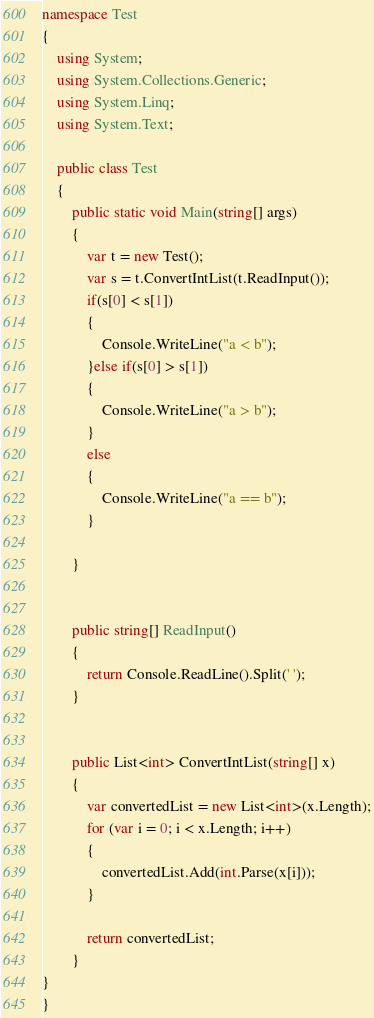<code> <loc_0><loc_0><loc_500><loc_500><_C#_>namespace Test
{
    using System;
    using System.Collections.Generic;
    using System.Linq;
    using System.Text;

    public class Test
    {
        public static void Main(string[] args)
        {
            var t = new Test();
            var s = t.ConvertIntList(t.ReadInput());
            if(s[0] < s[1])
            {
                Console.WriteLine("a < b");
            }else if(s[0] > s[1])
            {
                Console.WriteLine("a > b");
            }
            else
            {
                Console.WriteLine("a == b");
            }
           
        }


        public string[] ReadInput()
        {
            return Console.ReadLine().Split(' ');
        }


        public List<int> ConvertIntList(string[] x)
        {
            var convertedList = new List<int>(x.Length);
            for (var i = 0; i < x.Length; i++)
            {
                convertedList.Add(int.Parse(x[i]));
            }

            return convertedList;
        }
}
}

</code> 